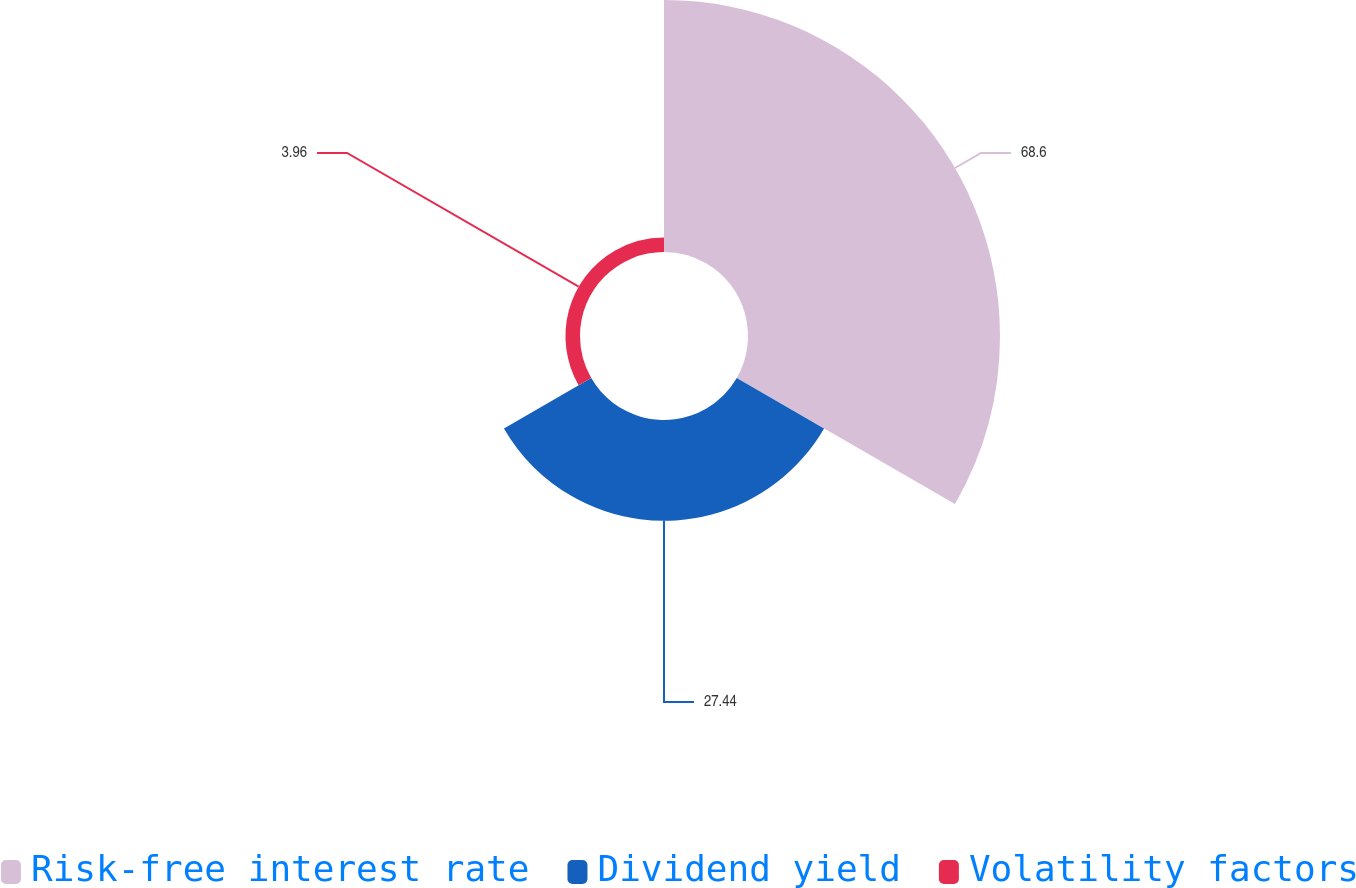<chart> <loc_0><loc_0><loc_500><loc_500><pie_chart><fcel>Risk-free interest rate<fcel>Dividend yield<fcel>Volatility factors<nl><fcel>68.6%<fcel>27.44%<fcel>3.96%<nl></chart> 